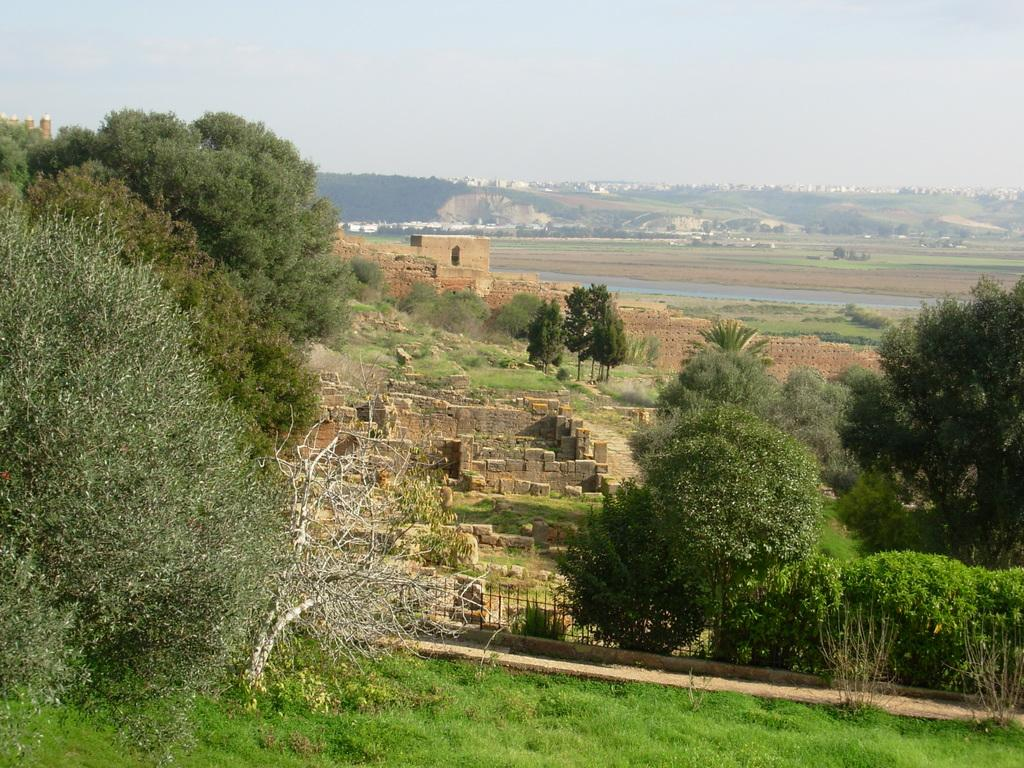What type of vegetation is predominant in the image? There are many trees in the image. What is the ground surface like in the image? There is a grass surface in the image. Can you describe any man-made structures in the image? There are some constructions in between the trees. What can be seen in the distance in the image? There are mountains visible in the background of the image. How many fish can be seen swimming in the grass surface in the image? There are no fish present in the image; it features trees, grass, constructions, and mountains. What type of grain is being harvested in the image? There is no grain harvesting depicted in the image. 